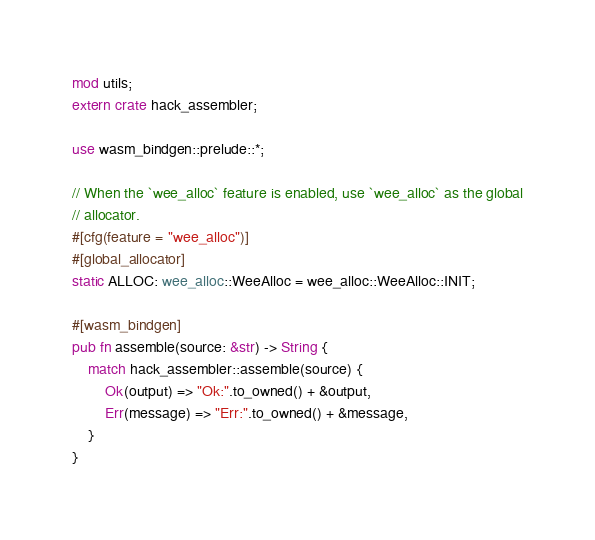Convert code to text. <code><loc_0><loc_0><loc_500><loc_500><_Rust_>mod utils;
extern crate hack_assembler;

use wasm_bindgen::prelude::*;

// When the `wee_alloc` feature is enabled, use `wee_alloc` as the global
// allocator.
#[cfg(feature = "wee_alloc")]
#[global_allocator]
static ALLOC: wee_alloc::WeeAlloc = wee_alloc::WeeAlloc::INIT;

#[wasm_bindgen]
pub fn assemble(source: &str) -> String {
    match hack_assembler::assemble(source) {
        Ok(output) => "Ok:".to_owned() + &output,
        Err(message) => "Err:".to_owned() + &message,
    }
}
</code> 